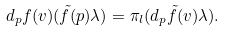Convert formula to latex. <formula><loc_0><loc_0><loc_500><loc_500>d _ { p } f ( v ) ( \tilde { f } ( p ) \lambda ) = \pi _ { l } ( d _ { p } \tilde { f } ( v ) \lambda ) .</formula> 